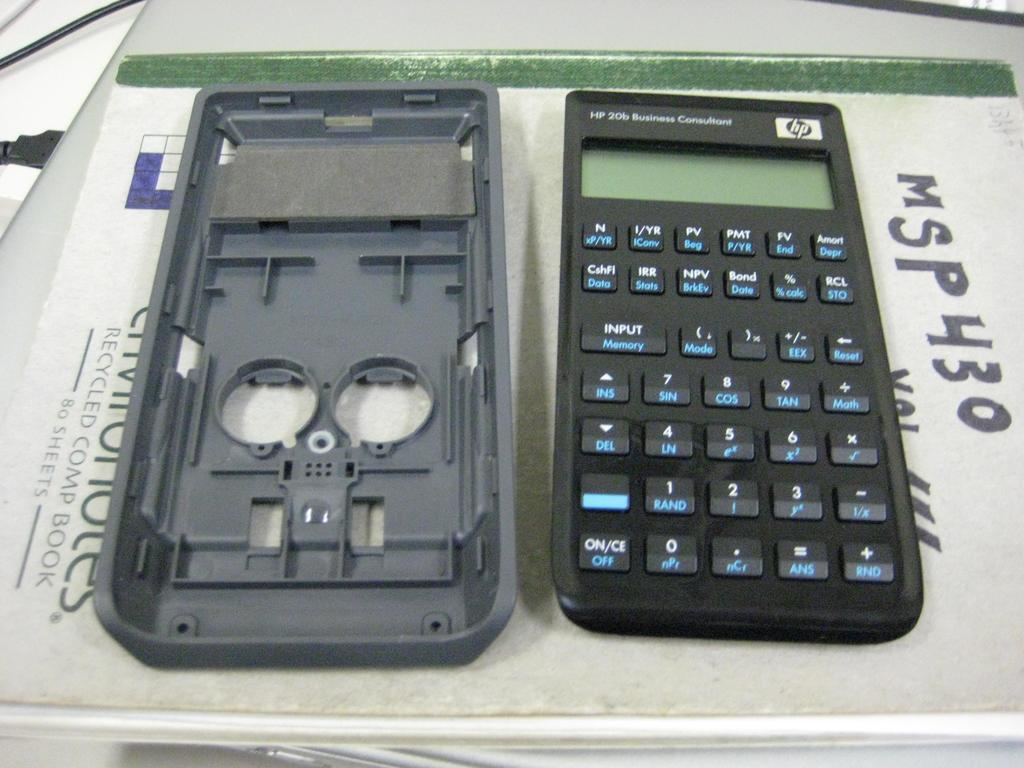<image>
Share a concise interpretation of the image provided. A calculator on top of a recycled comp book. 